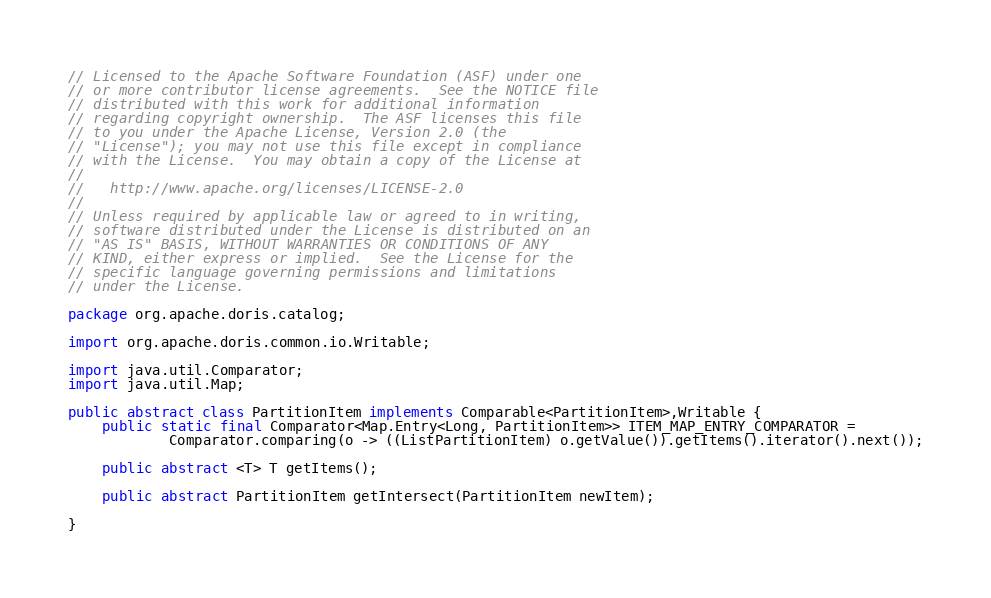Convert code to text. <code><loc_0><loc_0><loc_500><loc_500><_Java_>// Licensed to the Apache Software Foundation (ASF) under one
// or more contributor license agreements.  See the NOTICE file
// distributed with this work for additional information
// regarding copyright ownership.  The ASF licenses this file
// to you under the Apache License, Version 2.0 (the
// "License"); you may not use this file except in compliance
// with the License.  You may obtain a copy of the License at
//
//   http://www.apache.org/licenses/LICENSE-2.0
//
// Unless required by applicable law or agreed to in writing,
// software distributed under the License is distributed on an
// "AS IS" BASIS, WITHOUT WARRANTIES OR CONDITIONS OF ANY
// KIND, either express or implied.  See the License for the
// specific language governing permissions and limitations
// under the License.

package org.apache.doris.catalog;

import org.apache.doris.common.io.Writable;

import java.util.Comparator;
import java.util.Map;

public abstract class PartitionItem implements Comparable<PartitionItem>,Writable {
    public static final Comparator<Map.Entry<Long, PartitionItem>> ITEM_MAP_ENTRY_COMPARATOR =
            Comparator.comparing(o -> ((ListPartitionItem) o.getValue()).getItems().iterator().next());

    public abstract <T> T getItems();

    public abstract PartitionItem getIntersect(PartitionItem newItem);

}
</code> 